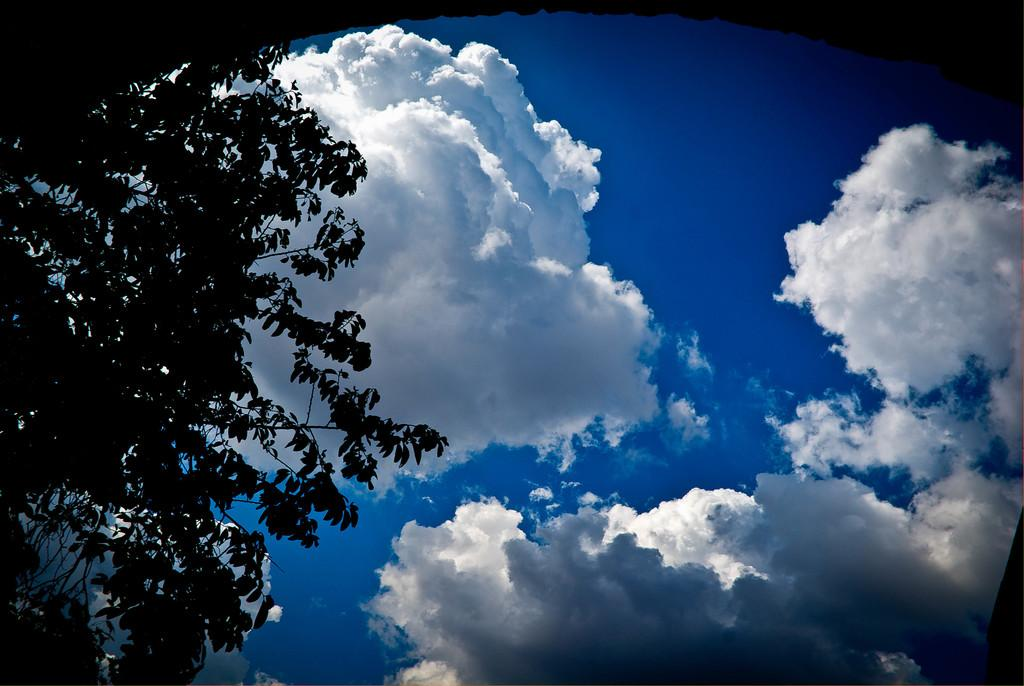What type of vegetation can be seen on the left side of the image? There are branches of trees on the left side of the image. What is visible in the background of the image? Sky is visible in the image. What can be observed in the sky? Clouds are present in the sky. What type of property can be seen on the right side of the image? There is no property visible on the right side of the image, as the facts only mention branches of trees on the left side and sky in the background. 